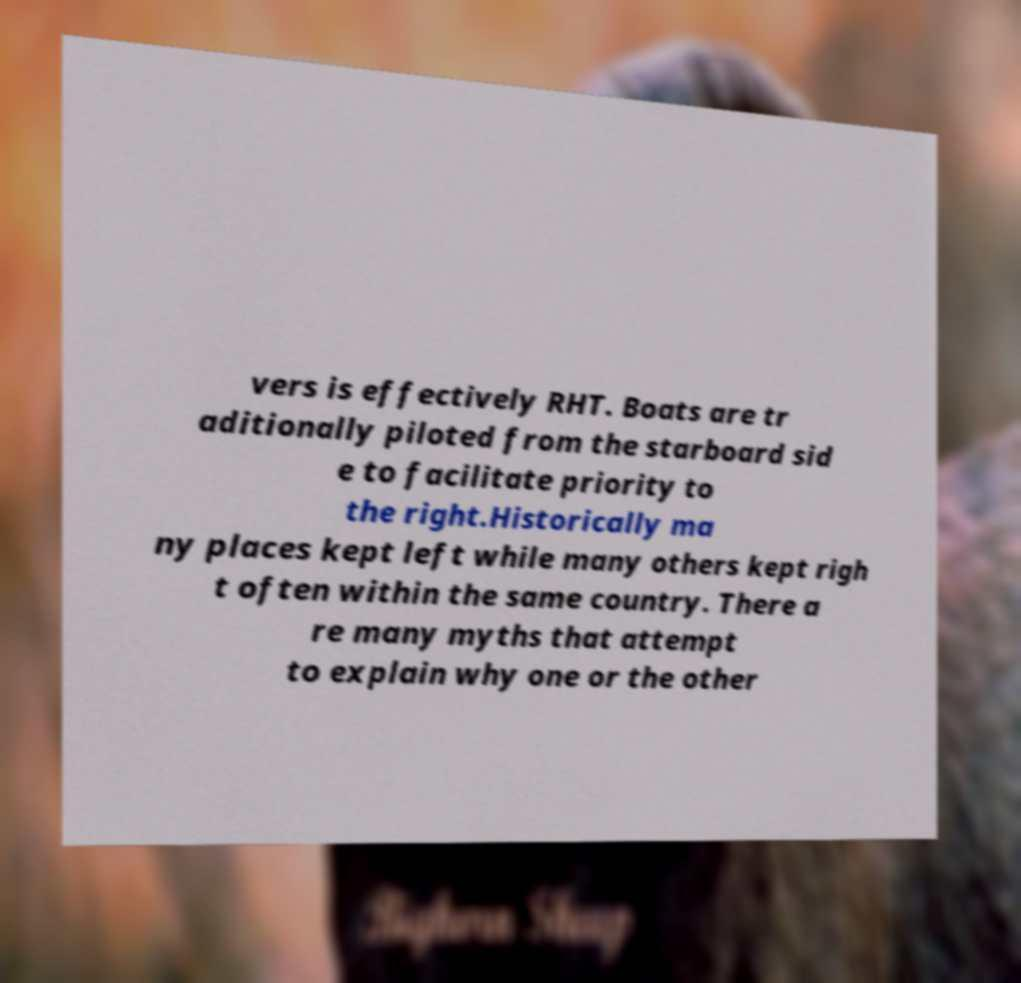What messages or text are displayed in this image? I need them in a readable, typed format. vers is effectively RHT. Boats are tr aditionally piloted from the starboard sid e to facilitate priority to the right.Historically ma ny places kept left while many others kept righ t often within the same country. There a re many myths that attempt to explain why one or the other 